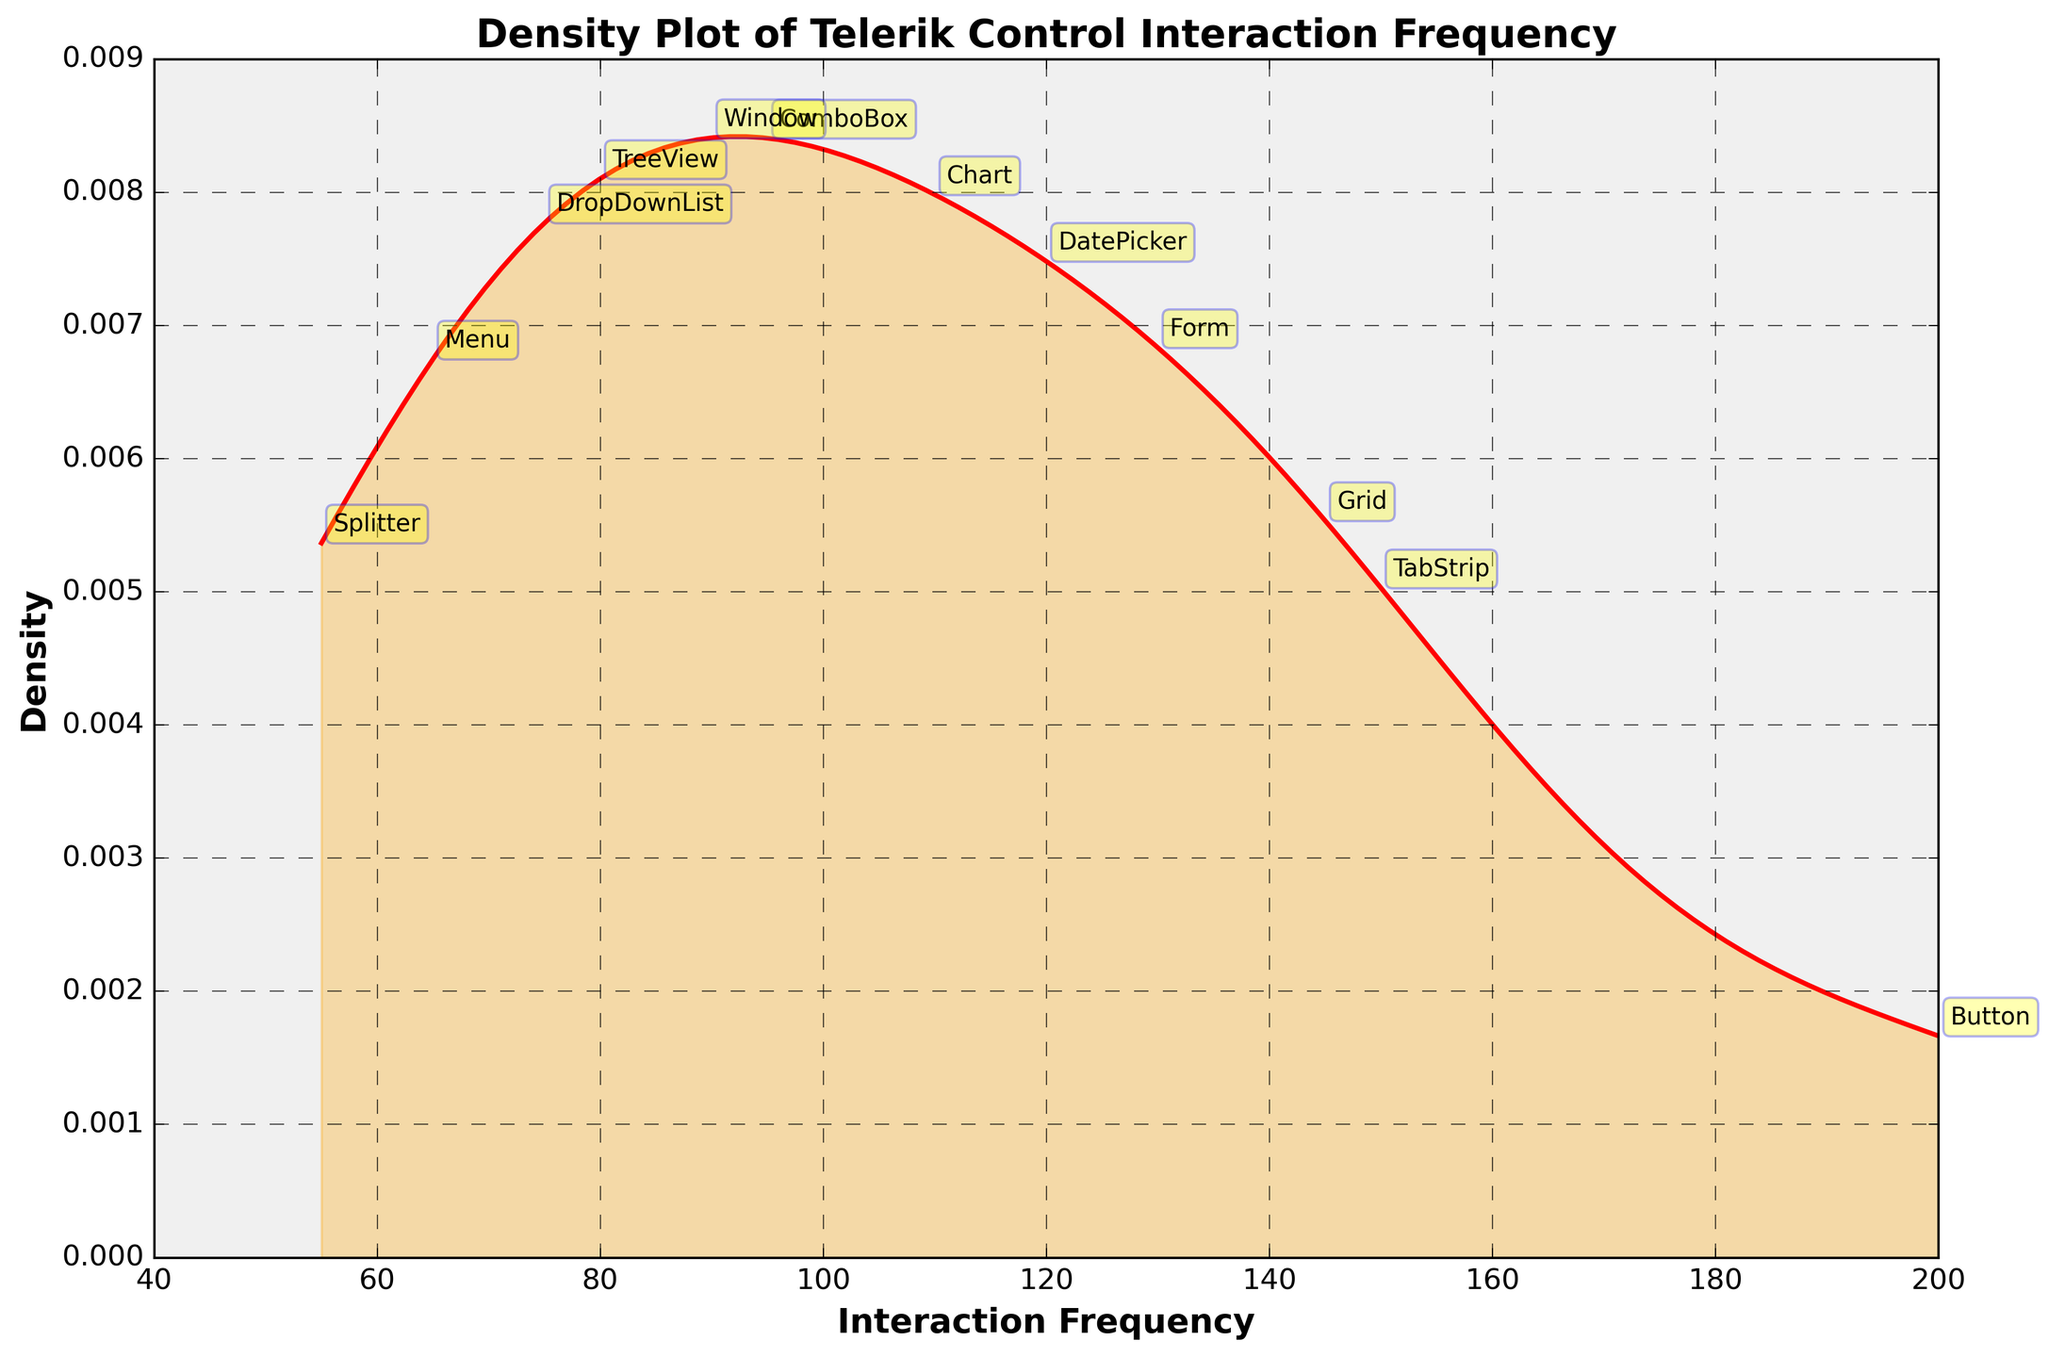What is the title of the plot? The title of the plot is located at the top and it clearly mentions the main subject of the visualization. The title is "Density Plot of Telerik Control Interaction Frequency".
Answer: Density Plot of Telerik Control Interaction Frequency What are the axis labels in the plot? The x-axis label is at the bottom of the plot, and the y-axis label is at the left side of the plot. The x-axis is labeled "Interaction Frequency", and the y-axis is labeled "Density".
Answer: Interaction Frequency and Density Which Telerik control has the highest interaction frequency? Annotated points on the plot show the interaction frequencies of various controls. The point with the highest frequency is labeled as "Button" at a value of 200.
Answer: Button How many Telerik controls have an interaction frequency greater than 100? Annotated points on the figure indicate the interaction frequencies of different controls. Counting those with values greater than 100 gives us 6 controls (Grid, DatePicker, Button, Chart, TabStrip, and Form).
Answer: 6 Which controls have frequencies between 90 and 150? Observing the annotated points, the controls with frequencies between 90 and 150 are ComboBox (95), DatePicker (120), Chart (110), Window (90), and TabStrip (150).
Answer: ComboBox, DatePicker, Chart, Window, TabStrip What is the lowest interaction frequency among the Telerik controls, and which control does it belong to? From the annotated points, the lowest frequency is observed at 55, which corresponds to the control labeled "Splitter".
Answer: Splitter In the density plot, where does the density peak approximately occur? The density curve peaks where the distribution is highest. Observing the curve, the peak appears around the range of 100-120 on the x-axis.
Answer: Around 100-120 What is the average interaction frequency of the 'Button' and 'Grid' controls? The frequencies of 'Button' and 'Grid' are annotated as 200 and 145, respectively. The average is calculated by (200 + 145) / 2 = 172.5.
Answer: 172.5 Which control's interaction frequency is closest to the peak of the density curve, and what is that frequency? The density curve peaks around 110-120. Among the points annotated near this range, the 'Chart' control with an interaction frequency of 110 is the closest.
Answer: Chart, 110 